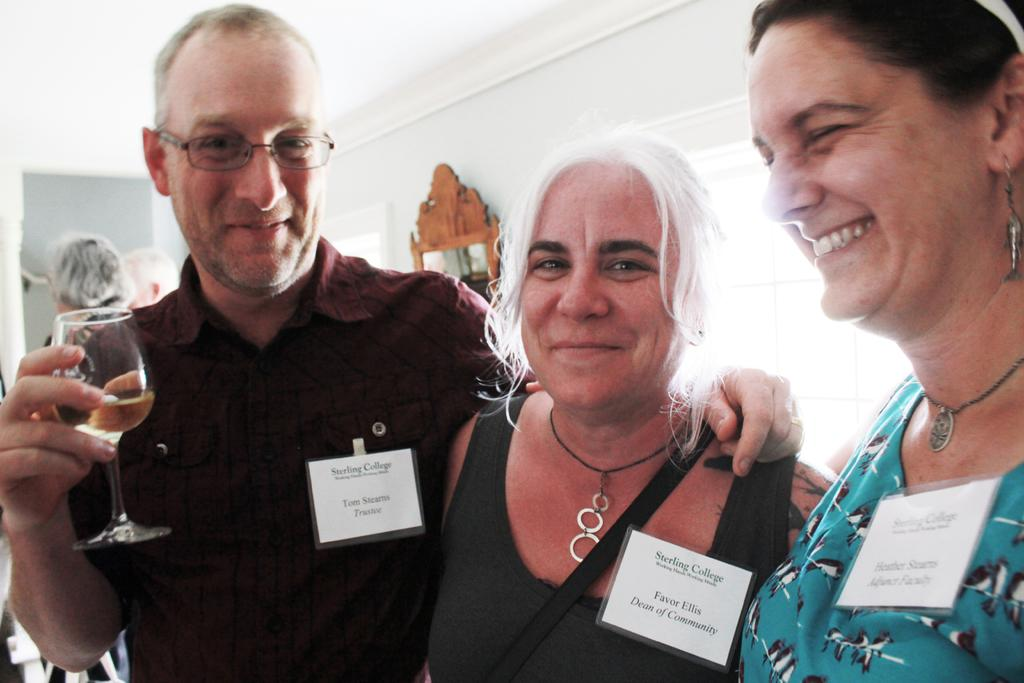How many people are in the image? There are three people in the image: two women and one man. Where are the women located in the image? The women are on the right side of the image. What are the women doing in the image? The women are smiling. Where is the man located in the image? The man is on the left side of the image. What is the man holding in his right hand? The man is holding a glass in his right hand. What is the man doing in the image? The man is smiling. What type of brick is the man using to tell a joke in the image? There is no brick or joke present in the image. The man is simply holding a glass and smiling. 